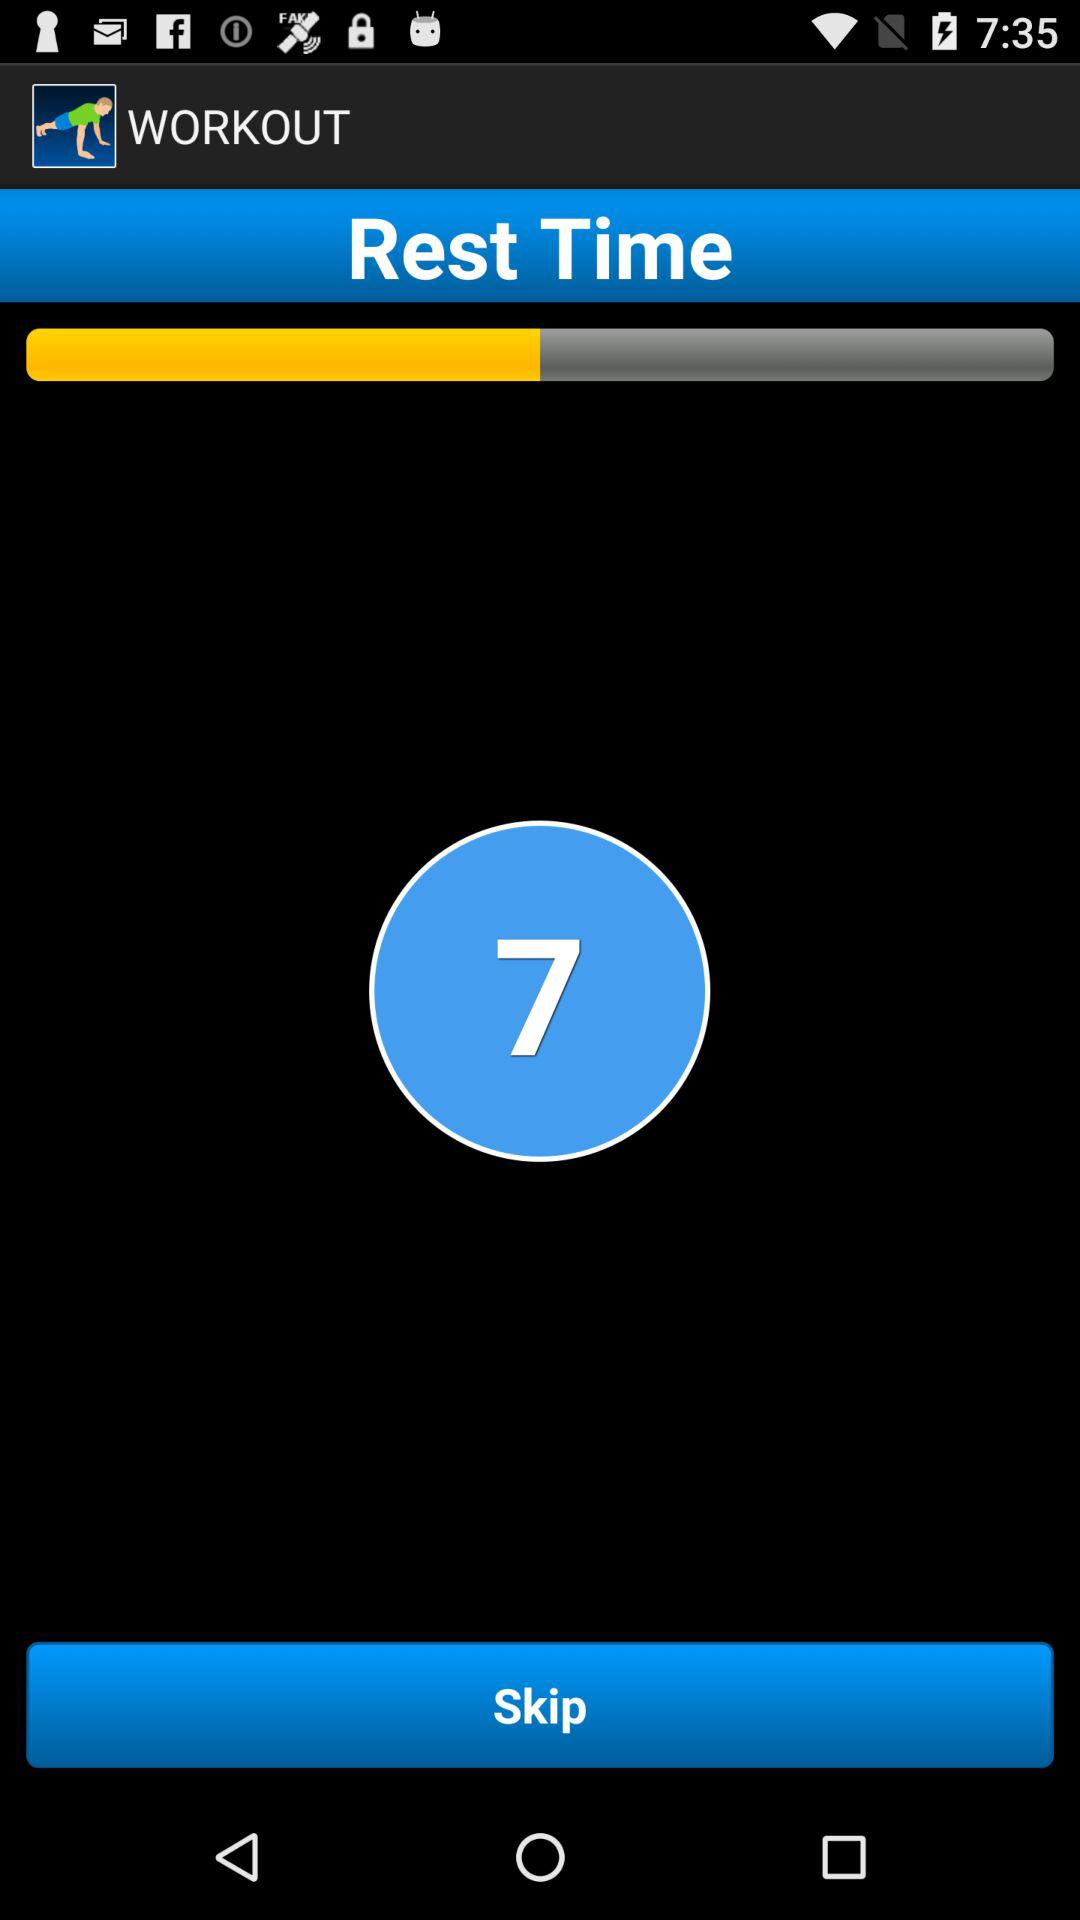Whose rest time is it?
When the provided information is insufficient, respond with <no answer>. <no answer> 